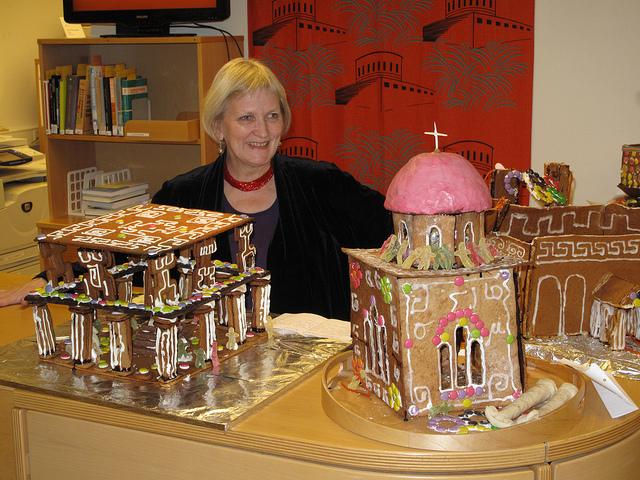How does the woman feel about her creations?
Write a very short answer. Happy. Can the model houses be eaten?
Answer briefly. Yes. What color is the bookshelf?
Give a very brief answer. Brown. 